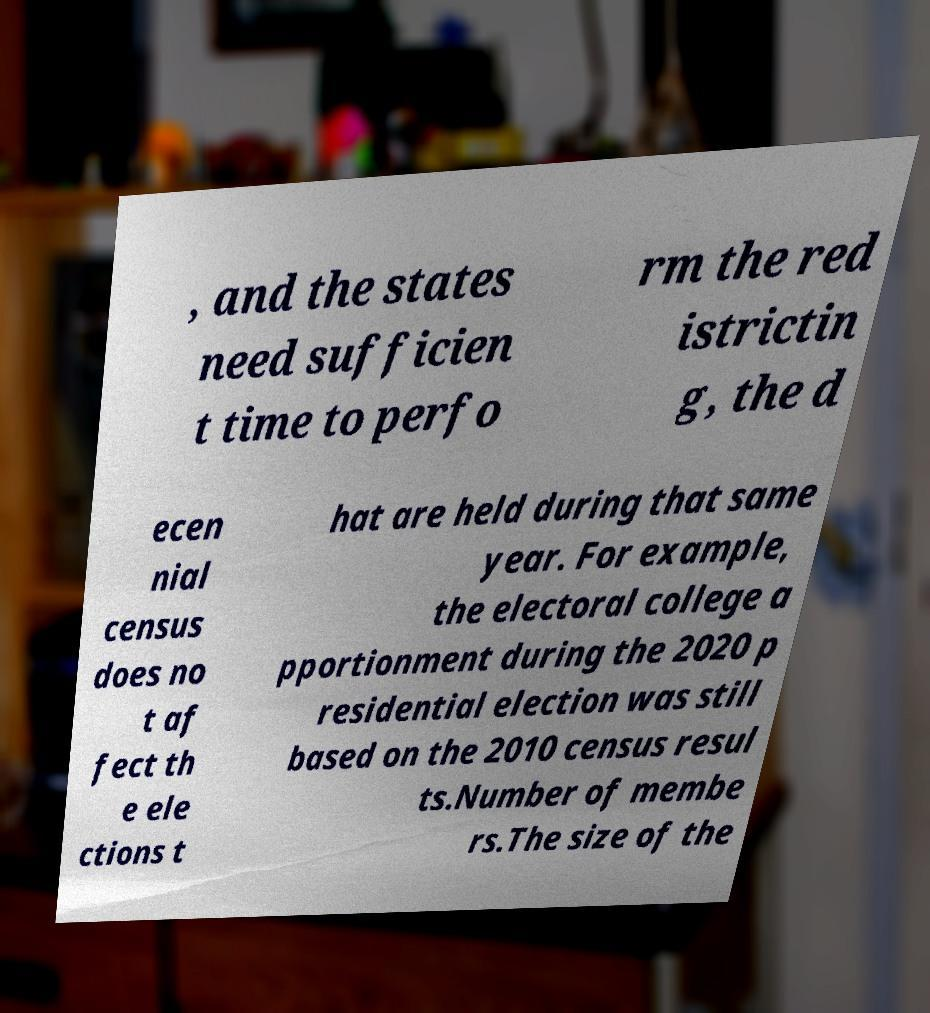Can you read and provide the text displayed in the image?This photo seems to have some interesting text. Can you extract and type it out for me? , and the states need sufficien t time to perfo rm the red istrictin g, the d ecen nial census does no t af fect th e ele ctions t hat are held during that same year. For example, the electoral college a pportionment during the 2020 p residential election was still based on the 2010 census resul ts.Number of membe rs.The size of the 